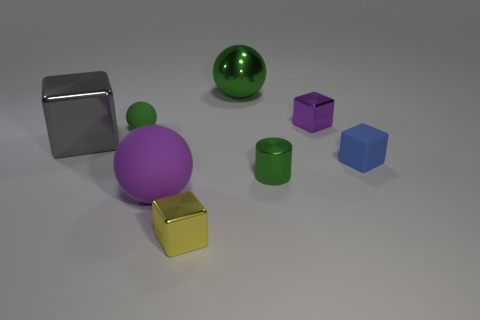How many other things are there of the same color as the tiny cylinder?
Make the answer very short. 2. How many tiny cyan spheres are there?
Provide a short and direct response. 0. Are there fewer rubber spheres that are to the left of the gray metal block than gray cubes?
Offer a terse response. Yes. Is the material of the sphere in front of the blue rubber block the same as the yellow thing?
Your response must be concise. No. There is a shiny object in front of the purple thing in front of the green object left of the tiny yellow metal block; what shape is it?
Your response must be concise. Cube. Are there any cylinders of the same size as the yellow metal block?
Your answer should be very brief. Yes. How big is the gray block?
Ensure brevity in your answer.  Large. What number of gray shiny cylinders have the same size as the yellow block?
Offer a very short reply. 0. Is the number of green balls in front of the tiny shiny cylinder less than the number of large gray cubes that are in front of the blue rubber block?
Ensure brevity in your answer.  No. What size is the thing that is to the right of the purple thing behind the small green thing to the left of the purple rubber object?
Give a very brief answer. Small. 